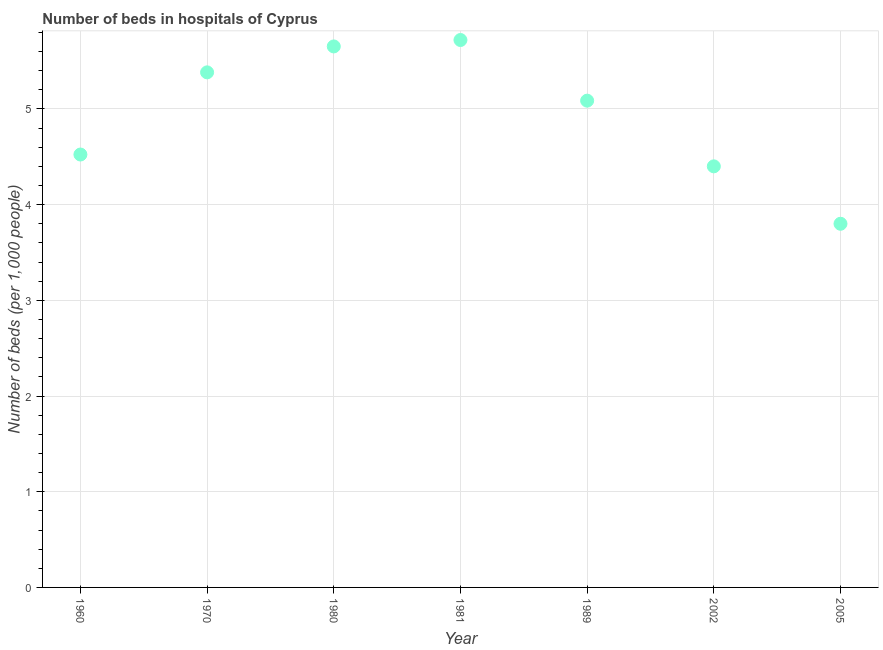What is the number of hospital beds in 1960?
Offer a very short reply. 4.52. Across all years, what is the maximum number of hospital beds?
Your response must be concise. 5.72. In which year was the number of hospital beds maximum?
Make the answer very short. 1981. What is the sum of the number of hospital beds?
Offer a terse response. 34.57. What is the difference between the number of hospital beds in 1970 and 2002?
Give a very brief answer. 0.98. What is the average number of hospital beds per year?
Keep it short and to the point. 4.94. What is the median number of hospital beds?
Your answer should be very brief. 5.09. Do a majority of the years between 2005 and 2002 (inclusive) have number of hospital beds greater than 4.6 %?
Offer a very short reply. No. What is the ratio of the number of hospital beds in 2002 to that in 2005?
Provide a short and direct response. 1.16. What is the difference between the highest and the second highest number of hospital beds?
Your response must be concise. 0.07. What is the difference between the highest and the lowest number of hospital beds?
Your answer should be compact. 1.92. Does the number of hospital beds monotonically increase over the years?
Keep it short and to the point. No. What is the difference between two consecutive major ticks on the Y-axis?
Keep it short and to the point. 1. Are the values on the major ticks of Y-axis written in scientific E-notation?
Offer a terse response. No. Does the graph contain any zero values?
Make the answer very short. No. Does the graph contain grids?
Your answer should be compact. Yes. What is the title of the graph?
Your response must be concise. Number of beds in hospitals of Cyprus. What is the label or title of the X-axis?
Give a very brief answer. Year. What is the label or title of the Y-axis?
Your answer should be compact. Number of beds (per 1,0 people). What is the Number of beds (per 1,000 people) in 1960?
Provide a short and direct response. 4.52. What is the Number of beds (per 1,000 people) in 1970?
Provide a short and direct response. 5.38. What is the Number of beds (per 1,000 people) in 1980?
Offer a very short reply. 5.65. What is the Number of beds (per 1,000 people) in 1981?
Your answer should be very brief. 5.72. What is the Number of beds (per 1,000 people) in 1989?
Make the answer very short. 5.09. What is the Number of beds (per 1,000 people) in 2002?
Ensure brevity in your answer.  4.4. What is the Number of beds (per 1,000 people) in 2005?
Keep it short and to the point. 3.8. What is the difference between the Number of beds (per 1,000 people) in 1960 and 1970?
Provide a short and direct response. -0.86. What is the difference between the Number of beds (per 1,000 people) in 1960 and 1980?
Give a very brief answer. -1.13. What is the difference between the Number of beds (per 1,000 people) in 1960 and 1981?
Offer a very short reply. -1.2. What is the difference between the Number of beds (per 1,000 people) in 1960 and 1989?
Your answer should be very brief. -0.56. What is the difference between the Number of beds (per 1,000 people) in 1960 and 2002?
Your answer should be very brief. 0.12. What is the difference between the Number of beds (per 1,000 people) in 1960 and 2005?
Your answer should be compact. 0.72. What is the difference between the Number of beds (per 1,000 people) in 1970 and 1980?
Your answer should be very brief. -0.27. What is the difference between the Number of beds (per 1,000 people) in 1970 and 1981?
Make the answer very short. -0.34. What is the difference between the Number of beds (per 1,000 people) in 1970 and 1989?
Provide a succinct answer. 0.3. What is the difference between the Number of beds (per 1,000 people) in 1970 and 2002?
Provide a succinct answer. 0.98. What is the difference between the Number of beds (per 1,000 people) in 1970 and 2005?
Make the answer very short. 1.58. What is the difference between the Number of beds (per 1,000 people) in 1980 and 1981?
Your answer should be very brief. -0.07. What is the difference between the Number of beds (per 1,000 people) in 1980 and 1989?
Your answer should be compact. 0.57. What is the difference between the Number of beds (per 1,000 people) in 1980 and 2002?
Offer a terse response. 1.25. What is the difference between the Number of beds (per 1,000 people) in 1980 and 2005?
Provide a short and direct response. 1.85. What is the difference between the Number of beds (per 1,000 people) in 1981 and 1989?
Provide a short and direct response. 0.63. What is the difference between the Number of beds (per 1,000 people) in 1981 and 2002?
Your response must be concise. 1.32. What is the difference between the Number of beds (per 1,000 people) in 1981 and 2005?
Your answer should be very brief. 1.92. What is the difference between the Number of beds (per 1,000 people) in 1989 and 2002?
Give a very brief answer. 0.69. What is the difference between the Number of beds (per 1,000 people) in 1989 and 2005?
Offer a terse response. 1.29. What is the difference between the Number of beds (per 1,000 people) in 2002 and 2005?
Keep it short and to the point. 0.6. What is the ratio of the Number of beds (per 1,000 people) in 1960 to that in 1970?
Ensure brevity in your answer.  0.84. What is the ratio of the Number of beds (per 1,000 people) in 1960 to that in 1980?
Give a very brief answer. 0.8. What is the ratio of the Number of beds (per 1,000 people) in 1960 to that in 1981?
Give a very brief answer. 0.79. What is the ratio of the Number of beds (per 1,000 people) in 1960 to that in 1989?
Offer a very short reply. 0.89. What is the ratio of the Number of beds (per 1,000 people) in 1960 to that in 2002?
Give a very brief answer. 1.03. What is the ratio of the Number of beds (per 1,000 people) in 1960 to that in 2005?
Provide a succinct answer. 1.19. What is the ratio of the Number of beds (per 1,000 people) in 1970 to that in 1981?
Offer a terse response. 0.94. What is the ratio of the Number of beds (per 1,000 people) in 1970 to that in 1989?
Your response must be concise. 1.06. What is the ratio of the Number of beds (per 1,000 people) in 1970 to that in 2002?
Your answer should be compact. 1.22. What is the ratio of the Number of beds (per 1,000 people) in 1970 to that in 2005?
Provide a short and direct response. 1.42. What is the ratio of the Number of beds (per 1,000 people) in 1980 to that in 1981?
Your response must be concise. 0.99. What is the ratio of the Number of beds (per 1,000 people) in 1980 to that in 1989?
Your answer should be very brief. 1.11. What is the ratio of the Number of beds (per 1,000 people) in 1980 to that in 2002?
Offer a very short reply. 1.28. What is the ratio of the Number of beds (per 1,000 people) in 1980 to that in 2005?
Make the answer very short. 1.49. What is the ratio of the Number of beds (per 1,000 people) in 1981 to that in 1989?
Provide a short and direct response. 1.12. What is the ratio of the Number of beds (per 1,000 people) in 1981 to that in 2005?
Provide a short and direct response. 1.5. What is the ratio of the Number of beds (per 1,000 people) in 1989 to that in 2002?
Give a very brief answer. 1.16. What is the ratio of the Number of beds (per 1,000 people) in 1989 to that in 2005?
Your answer should be very brief. 1.34. What is the ratio of the Number of beds (per 1,000 people) in 2002 to that in 2005?
Provide a succinct answer. 1.16. 